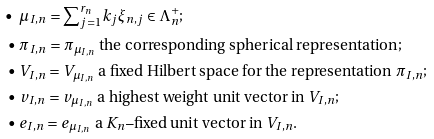Convert formula to latex. <formula><loc_0><loc_0><loc_500><loc_500>\bullet \ & \mu _ { I , n } = { \sum } _ { j = 1 } ^ { r _ { n } } k _ { j } \xi _ { n , j } \in \Lambda ^ { + } _ { n } ; \\ \bullet \ & \pi _ { I , n } = \pi _ { \mu _ { I , n } } \text { the corresponding spherical representation} ; \\ \bullet \ & V _ { I , n } = V _ { \mu _ { I , n } } \text { a fixed Hilbert space for the representation } \pi _ { I , n } ; \\ \bullet \ & v _ { I , n } = v _ { \mu _ { I , n } } \text { a highest weight unit vector in } V _ { I , n } ; \\ \bullet \ & e _ { I , n } = e _ { \mu _ { I , n } } \text { a } K _ { n } \text {--fixed unit vector in } V _ { I , n } .</formula> 